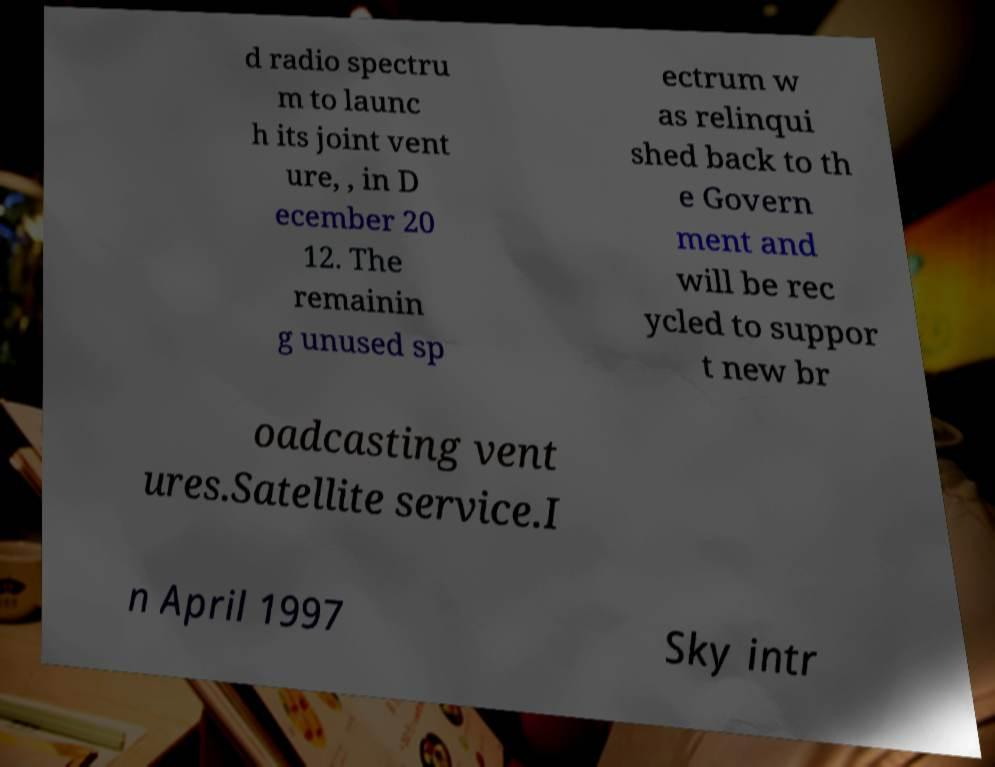What messages or text are displayed in this image? I need them in a readable, typed format. d radio spectru m to launc h its joint vent ure, , in D ecember 20 12. The remainin g unused sp ectrum w as relinqui shed back to th e Govern ment and will be rec ycled to suppor t new br oadcasting vent ures.Satellite service.I n April 1997 Sky intr 